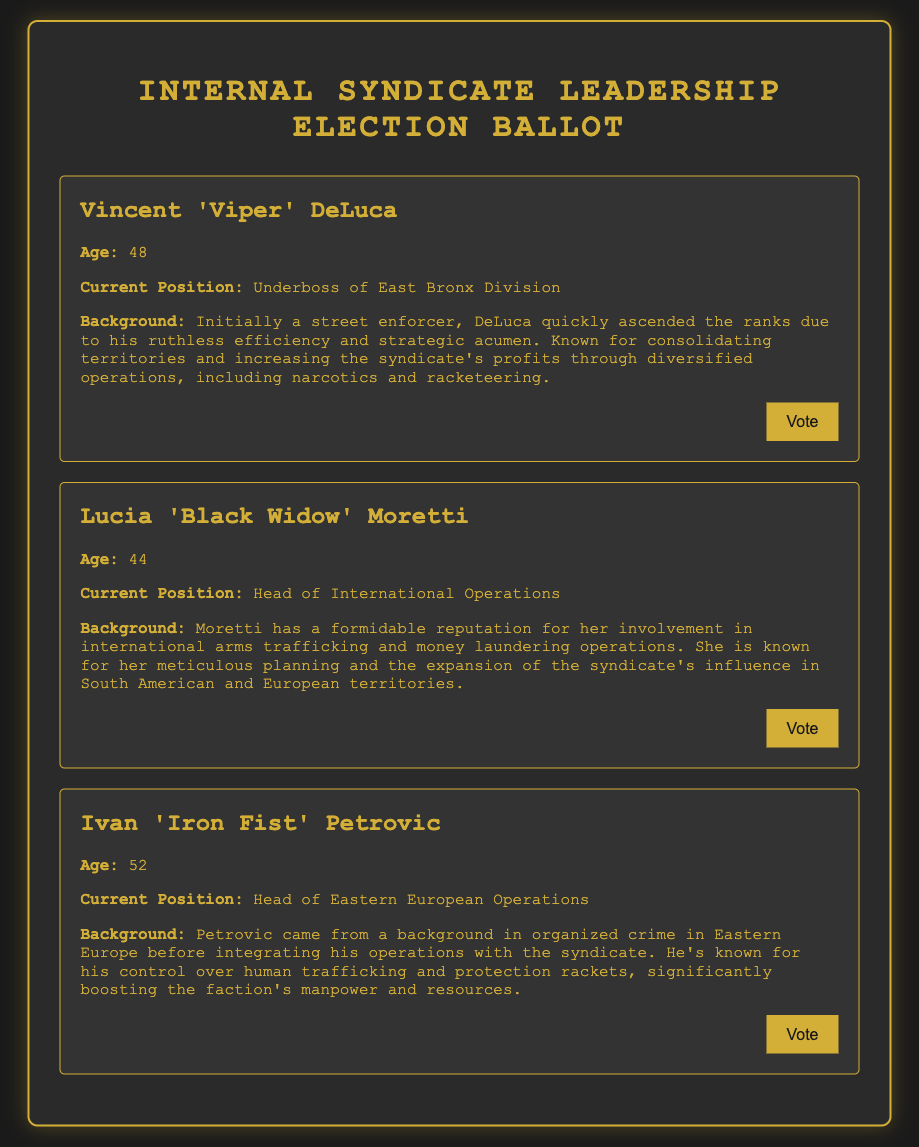What is the name of the candidate who is 48 years old? The candidate who is 48 years old is Vincent 'Viper' DeLuca.
Answer: Vincent 'Viper' DeLuca What position does Lucia 'Black Widow' Moretti currently hold? Lucia 'Black Widow' Moretti currently holds the position of Head of International Operations.
Answer: Head of International Operations What is Ivan 'Iron Fist' Petrovic's background in organized crime? Ivan 'Iron Fist' Petrovic has a background in organized crime in Eastern Europe before integrating his operations with the syndicate.
Answer: Eastern Europe How old is Vincent 'Viper' DeLuca? Vincent 'Viper' DeLuca is 48 years old.
Answer: 48 Which candidate is known for international arms trafficking? The candidate known for international arms trafficking is Lucia 'Black Widow' Moretti.
Answer: Lucia 'Black Widow' Moretti What key operation does Ivan 'Iron Fist' Petrovic control? Ivan 'Iron Fist' Petrovic controls human trafficking.
Answer: Human trafficking How many candidates are listed in the ballot? The ballot lists three candidates.
Answer: Three What is the main strength of Lucia 'Black Widow' Moretti as per the document? Lucia 'Black Widow' Moretti is known for her meticulous planning and expansion of the syndicate's influence.
Answer: Meticulous planning and expansion What is the color scheme of the ballot document? The color scheme includes dark backgrounds with gold text and accents.
Answer: Dark backgrounds with gold text and accents 